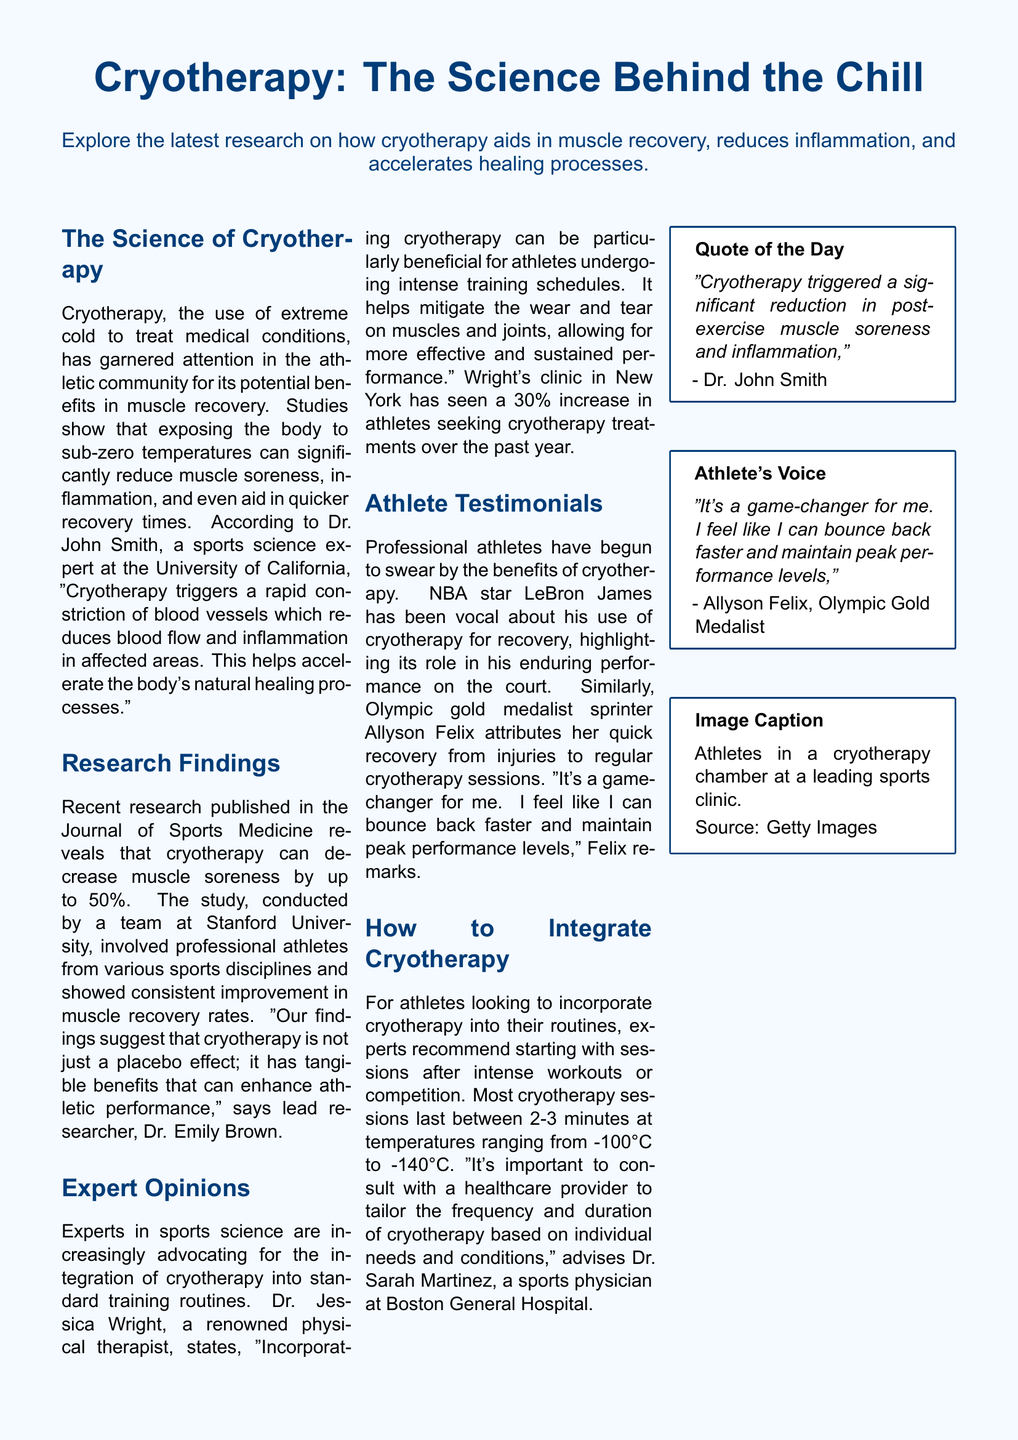What is the main focus of the document? The document explores the latest research on cryotherapy's benefits for athletes, including its impact on muscle recovery and inflammation.
Answer: Cryotherapy benefits for athletes Who is a notable athlete mentioned in the document? The document features testimonials from athletes, including NBA star LeBron James and Olympic gold medalist Allyson Felix.
Answer: LeBron James What percentage decrease in muscle soreness does cryotherapy reportedly provide? According to the research mentioned, cryotherapy can decrease muscle soreness by up to 50%.
Answer: 50% What is the typical duration of cryotherapy sessions? Experts recommend that most cryotherapy sessions last between 2-3 minutes.
Answer: 2-3 minutes What role does Dr. John Smith have in the document? Dr. John Smith is identified as a sports science expert at the University of California.
Answer: Sports science expert According to Dr. Jessica Wright, what has been the increase in athletes seeking cryotherapy treatments? Dr. Jessica Wright's clinic has seen a 30% increase in athletes seeking cryotherapy treatments over the past year.
Answer: 30% What is the temperature range for cryotherapy sessions mentioned in the document? The document states that cryotherapy sessions are conducted at temperatures ranging from -100°C to -140°C.
Answer: -100°C to -140°C What does Dr. Sarah Martinez recommend before starting cryotherapy? Dr. Sarah Martinez advises consulting with a healthcare provider to tailor the treatment based on individual needs and conditions.
Answer: Consult with a healthcare provider What publication featured the recent research on cryotherapy? The research on cryotherapy was published in the Journal of Sports Medicine.
Answer: Journal of Sports Medicine 